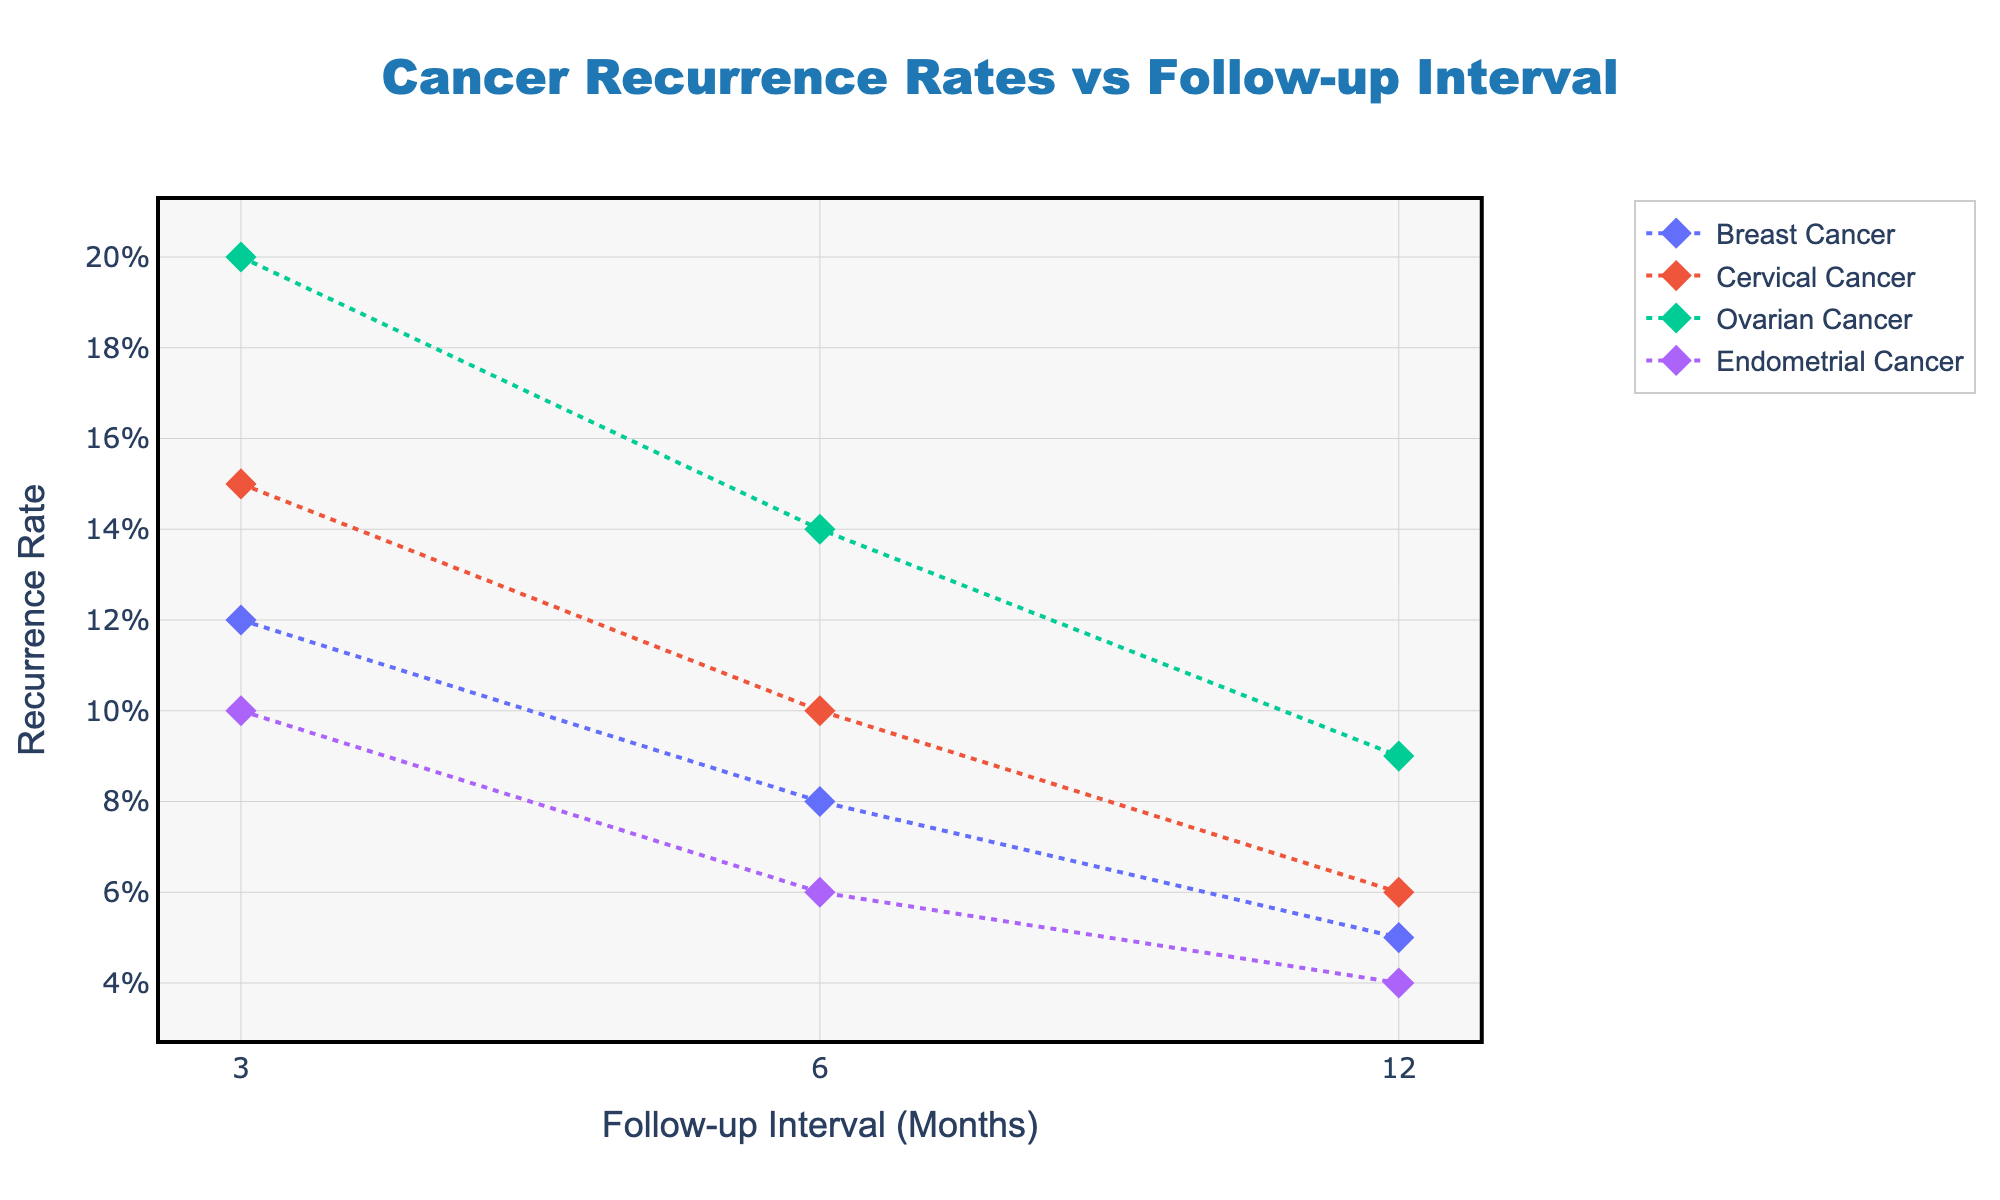What is the title of the scatter plot? The title is prominently displayed at the top of the figure in large, bold text. It reads "Cancer Recurrence Rates vs Follow-up Interval."
Answer: Cancer Recurrence Rates vs Follow-up Interval What does the x-axis represent? The label on the x-axis indicates that it represents the "Follow-up Interval (Months)" and it uses a log scale with tick marks at 3, 6, and 12 months.
Answer: Follow-up Interval (Months) Which cancer type has the highest recurrence rate at the 3-month follow-up interval? By looking at the leftmost data points on the scatter plot, the one with the highest recurrence rate at 3 months is the point for Ovarian Cancer.
Answer: Ovarian Cancer How does the recurrence rate for Breast Cancer change across the follow-up intervals? Checking the line for Breast Cancer, the recurrence rate decreases from 0.12 at 3 months, to 0.08 at 6 months, and to 0.05 at 12 months.
Answer: It decreases Which two cancer types have the same recurrence rate at the 12-month follow-up interval? Observing the 12-month follow-up interval on the plot, both Cervical Cancer and Endometrial Cancer have the same recurrence rate of 0.06.
Answer: Cervical Cancer and Endometrial Cancer Is there a trend in the recurrence rate as the follow-up interval increases? The recurrence rates for all cancer types generally show a decreasing trend as the follow-up interval increases from 3 to 12 months.
Answer: Decreasing trend Which cancer type shows the largest decrease in recurrence rate from 3 months to 12 months? Calculate the change in recurrence rate for each cancer type from 3 months to 12 months: Breast Cancer decreases by 0.07, Cervical Cancer by 0.09, Ovarian Cancer by 0.11, and Endometrial Cancer by 0.06. Ovarian Cancer shows the largest decrease.
Answer: Ovarian Cancer At what follow-up interval do Breast Cancer and Endometrial Cancer have the same recurrence rate? By tracing the lines for Breast Cancer and Endometrial Cancer across the intervals, they intersect at the 12-month follow-up interval with a recurrence rate of 0.05.
Answer: 12 months 